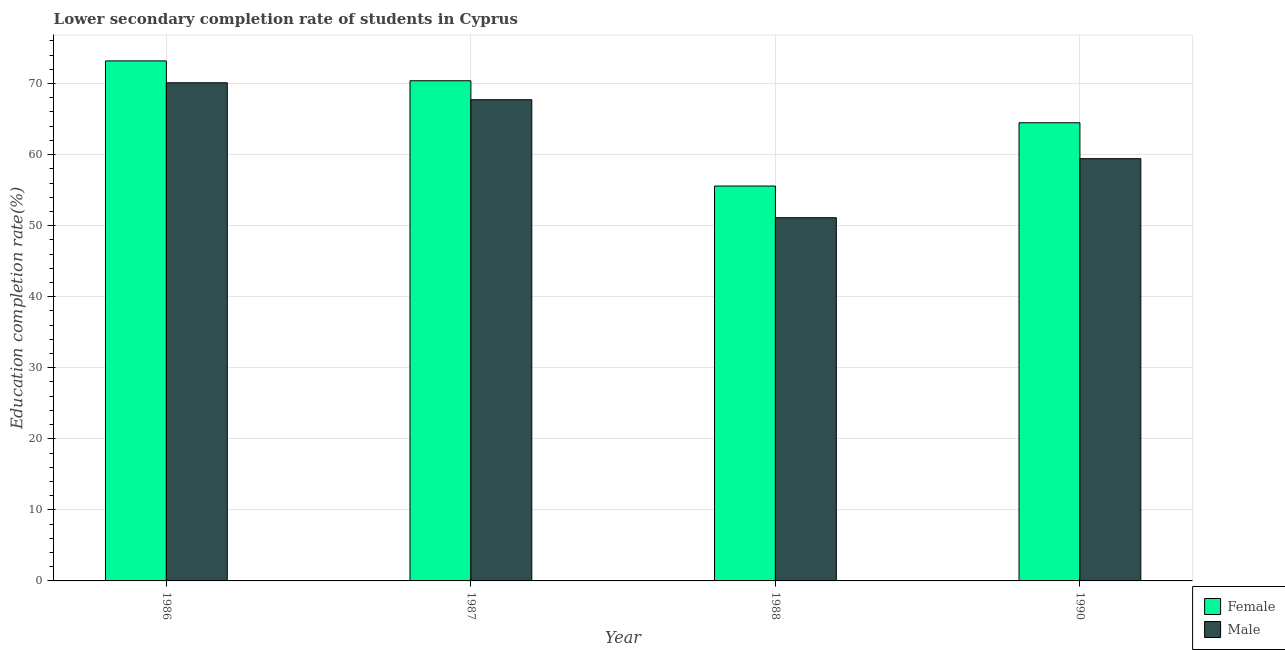How many different coloured bars are there?
Keep it short and to the point. 2. Are the number of bars on each tick of the X-axis equal?
Keep it short and to the point. Yes. What is the education completion rate of male students in 1988?
Provide a short and direct response. 51.12. Across all years, what is the maximum education completion rate of male students?
Provide a short and direct response. 70.11. Across all years, what is the minimum education completion rate of female students?
Ensure brevity in your answer.  55.58. In which year was the education completion rate of female students maximum?
Give a very brief answer. 1986. What is the total education completion rate of male students in the graph?
Make the answer very short. 248.37. What is the difference between the education completion rate of female students in 1987 and that in 1988?
Offer a terse response. 14.82. What is the difference between the education completion rate of female students in 1990 and the education completion rate of male students in 1987?
Make the answer very short. -5.91. What is the average education completion rate of female students per year?
Keep it short and to the point. 65.91. In the year 1990, what is the difference between the education completion rate of male students and education completion rate of female students?
Ensure brevity in your answer.  0. In how many years, is the education completion rate of female students greater than 32 %?
Provide a succinct answer. 4. What is the ratio of the education completion rate of female students in 1986 to that in 1990?
Ensure brevity in your answer.  1.14. Is the education completion rate of male students in 1988 less than that in 1990?
Give a very brief answer. Yes. What is the difference between the highest and the second highest education completion rate of female students?
Provide a short and direct response. 2.8. What is the difference between the highest and the lowest education completion rate of female students?
Offer a very short reply. 17.61. In how many years, is the education completion rate of male students greater than the average education completion rate of male students taken over all years?
Keep it short and to the point. 2. What does the 1st bar from the right in 1988 represents?
Ensure brevity in your answer.  Male. Are all the bars in the graph horizontal?
Offer a terse response. No. How many years are there in the graph?
Provide a short and direct response. 4. What is the difference between two consecutive major ticks on the Y-axis?
Your answer should be compact. 10. Are the values on the major ticks of Y-axis written in scientific E-notation?
Provide a short and direct response. No. Does the graph contain any zero values?
Make the answer very short. No. Does the graph contain grids?
Your response must be concise. Yes. How many legend labels are there?
Your response must be concise. 2. What is the title of the graph?
Offer a terse response. Lower secondary completion rate of students in Cyprus. What is the label or title of the X-axis?
Offer a terse response. Year. What is the label or title of the Y-axis?
Offer a very short reply. Education completion rate(%). What is the Education completion rate(%) of Female in 1986?
Ensure brevity in your answer.  73.19. What is the Education completion rate(%) in Male in 1986?
Your answer should be compact. 70.11. What is the Education completion rate(%) in Female in 1987?
Your answer should be compact. 70.39. What is the Education completion rate(%) in Male in 1987?
Offer a very short reply. 67.72. What is the Education completion rate(%) of Female in 1988?
Your response must be concise. 55.58. What is the Education completion rate(%) of Male in 1988?
Give a very brief answer. 51.12. What is the Education completion rate(%) of Female in 1990?
Provide a succinct answer. 64.48. What is the Education completion rate(%) of Male in 1990?
Give a very brief answer. 59.43. Across all years, what is the maximum Education completion rate(%) of Female?
Provide a succinct answer. 73.19. Across all years, what is the maximum Education completion rate(%) in Male?
Provide a short and direct response. 70.11. Across all years, what is the minimum Education completion rate(%) in Female?
Your response must be concise. 55.58. Across all years, what is the minimum Education completion rate(%) of Male?
Provide a short and direct response. 51.12. What is the total Education completion rate(%) in Female in the graph?
Keep it short and to the point. 263.64. What is the total Education completion rate(%) of Male in the graph?
Provide a succinct answer. 248.37. What is the difference between the Education completion rate(%) of Female in 1986 and that in 1987?
Your answer should be compact. 2.8. What is the difference between the Education completion rate(%) in Male in 1986 and that in 1987?
Ensure brevity in your answer.  2.39. What is the difference between the Education completion rate(%) of Female in 1986 and that in 1988?
Your answer should be very brief. 17.61. What is the difference between the Education completion rate(%) of Male in 1986 and that in 1988?
Ensure brevity in your answer.  18.99. What is the difference between the Education completion rate(%) of Female in 1986 and that in 1990?
Your answer should be compact. 8.71. What is the difference between the Education completion rate(%) of Male in 1986 and that in 1990?
Ensure brevity in your answer.  10.68. What is the difference between the Education completion rate(%) in Female in 1987 and that in 1988?
Make the answer very short. 14.82. What is the difference between the Education completion rate(%) in Male in 1987 and that in 1988?
Offer a very short reply. 16.6. What is the difference between the Education completion rate(%) of Female in 1987 and that in 1990?
Offer a very short reply. 5.91. What is the difference between the Education completion rate(%) in Male in 1987 and that in 1990?
Ensure brevity in your answer.  8.3. What is the difference between the Education completion rate(%) of Female in 1988 and that in 1990?
Give a very brief answer. -8.91. What is the difference between the Education completion rate(%) of Male in 1988 and that in 1990?
Give a very brief answer. -8.31. What is the difference between the Education completion rate(%) of Female in 1986 and the Education completion rate(%) of Male in 1987?
Your answer should be compact. 5.47. What is the difference between the Education completion rate(%) of Female in 1986 and the Education completion rate(%) of Male in 1988?
Make the answer very short. 22.07. What is the difference between the Education completion rate(%) of Female in 1986 and the Education completion rate(%) of Male in 1990?
Offer a very short reply. 13.77. What is the difference between the Education completion rate(%) in Female in 1987 and the Education completion rate(%) in Male in 1988?
Offer a very short reply. 19.27. What is the difference between the Education completion rate(%) in Female in 1987 and the Education completion rate(%) in Male in 1990?
Make the answer very short. 10.97. What is the difference between the Education completion rate(%) in Female in 1988 and the Education completion rate(%) in Male in 1990?
Give a very brief answer. -3.85. What is the average Education completion rate(%) of Female per year?
Make the answer very short. 65.91. What is the average Education completion rate(%) in Male per year?
Give a very brief answer. 62.09. In the year 1986, what is the difference between the Education completion rate(%) of Female and Education completion rate(%) of Male?
Offer a very short reply. 3.08. In the year 1987, what is the difference between the Education completion rate(%) in Female and Education completion rate(%) in Male?
Your answer should be compact. 2.67. In the year 1988, what is the difference between the Education completion rate(%) in Female and Education completion rate(%) in Male?
Offer a terse response. 4.46. In the year 1990, what is the difference between the Education completion rate(%) in Female and Education completion rate(%) in Male?
Your answer should be compact. 5.06. What is the ratio of the Education completion rate(%) in Female in 1986 to that in 1987?
Ensure brevity in your answer.  1.04. What is the ratio of the Education completion rate(%) of Male in 1986 to that in 1987?
Offer a very short reply. 1.04. What is the ratio of the Education completion rate(%) of Female in 1986 to that in 1988?
Ensure brevity in your answer.  1.32. What is the ratio of the Education completion rate(%) in Male in 1986 to that in 1988?
Give a very brief answer. 1.37. What is the ratio of the Education completion rate(%) in Female in 1986 to that in 1990?
Give a very brief answer. 1.14. What is the ratio of the Education completion rate(%) of Male in 1986 to that in 1990?
Your answer should be compact. 1.18. What is the ratio of the Education completion rate(%) in Female in 1987 to that in 1988?
Offer a terse response. 1.27. What is the ratio of the Education completion rate(%) of Male in 1987 to that in 1988?
Offer a very short reply. 1.32. What is the ratio of the Education completion rate(%) in Female in 1987 to that in 1990?
Give a very brief answer. 1.09. What is the ratio of the Education completion rate(%) of Male in 1987 to that in 1990?
Your response must be concise. 1.14. What is the ratio of the Education completion rate(%) of Female in 1988 to that in 1990?
Your answer should be compact. 0.86. What is the ratio of the Education completion rate(%) of Male in 1988 to that in 1990?
Offer a very short reply. 0.86. What is the difference between the highest and the second highest Education completion rate(%) of Female?
Your answer should be compact. 2.8. What is the difference between the highest and the second highest Education completion rate(%) of Male?
Make the answer very short. 2.39. What is the difference between the highest and the lowest Education completion rate(%) of Female?
Ensure brevity in your answer.  17.61. What is the difference between the highest and the lowest Education completion rate(%) in Male?
Provide a short and direct response. 18.99. 